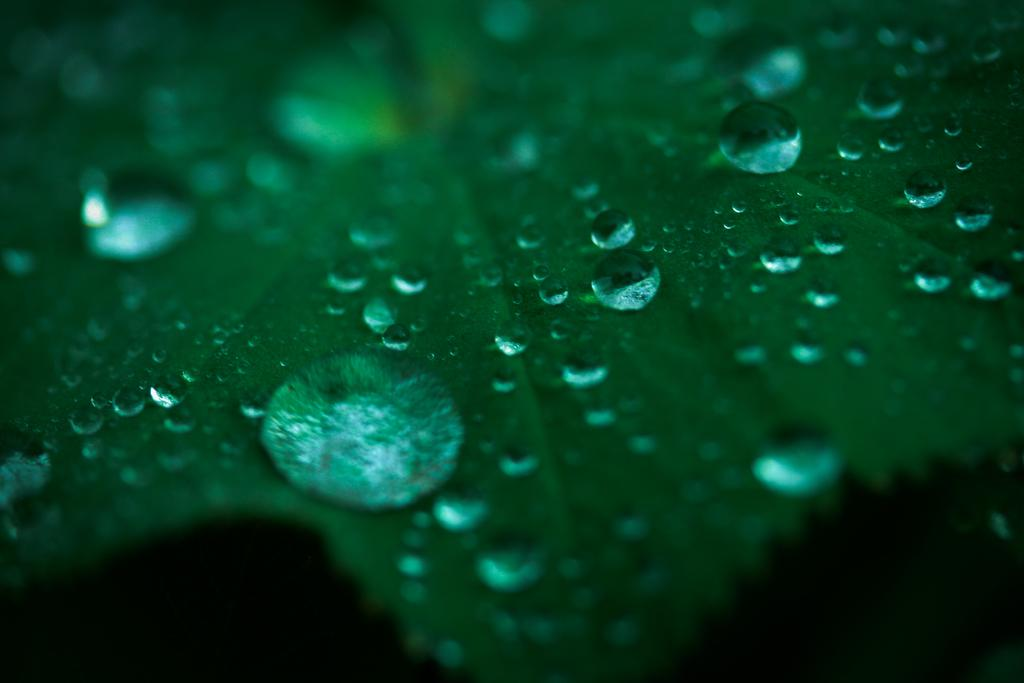What color is the object in the image? The object in the image is green. Can you describe the appearance of the green object? There are water drops on the green object. Where is the lunchroom located in the image? There is no mention of a lunchroom in the image or the provided facts. 